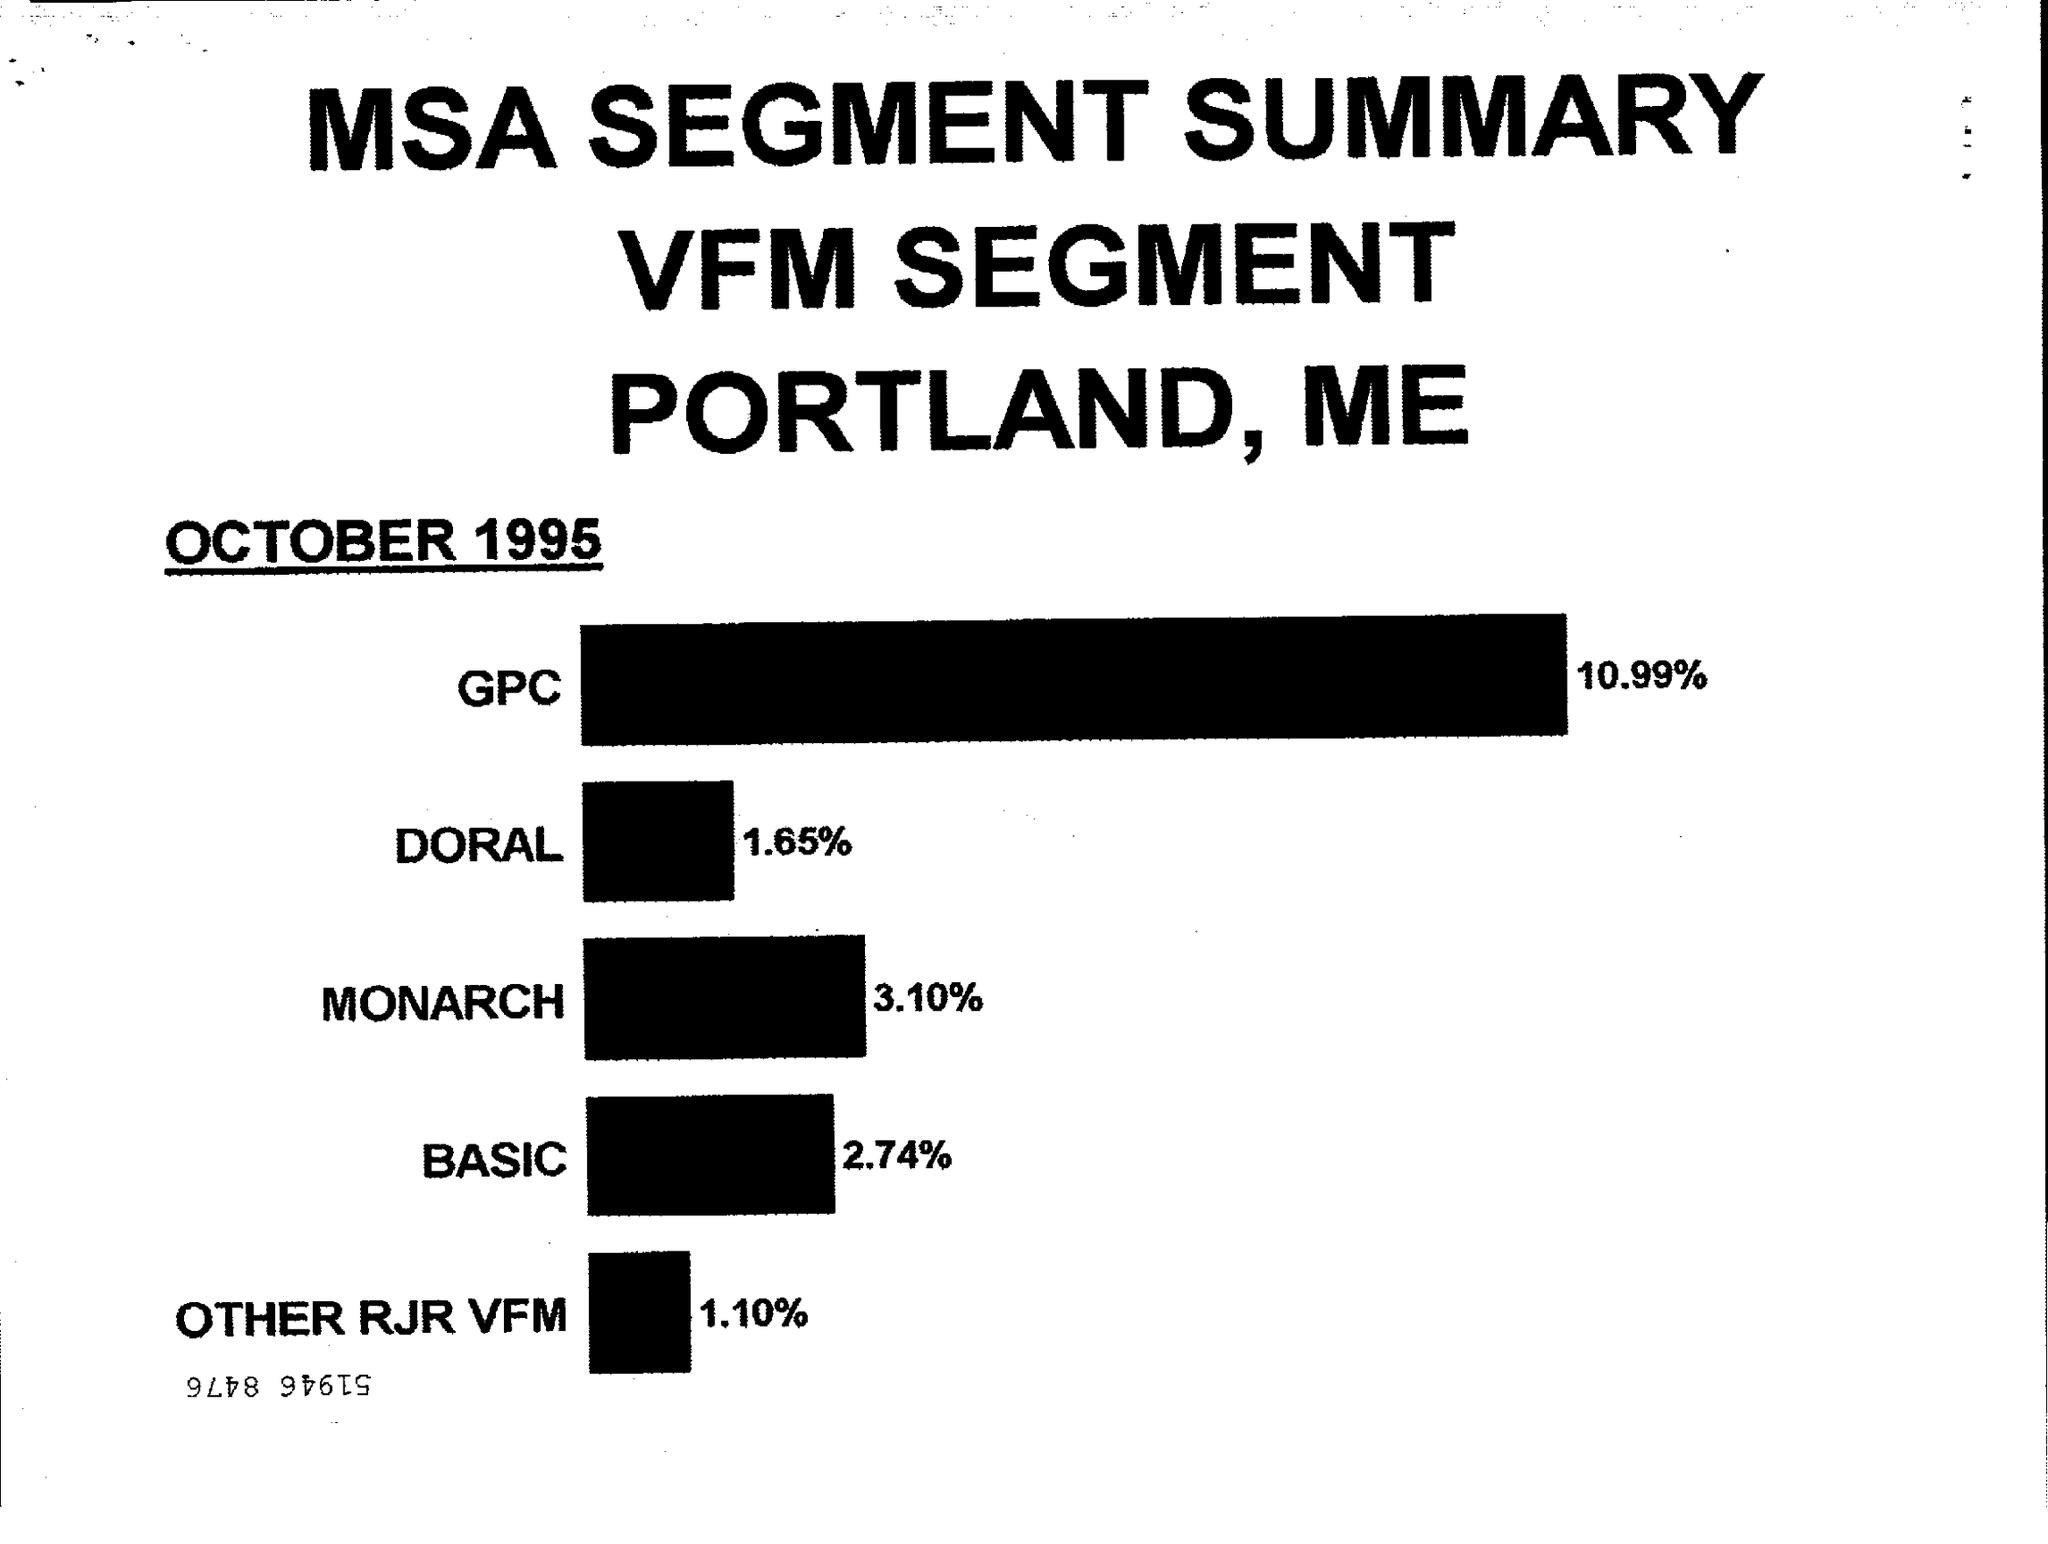List a handful of essential elements in this visual. The document is dated as of October 1995. 